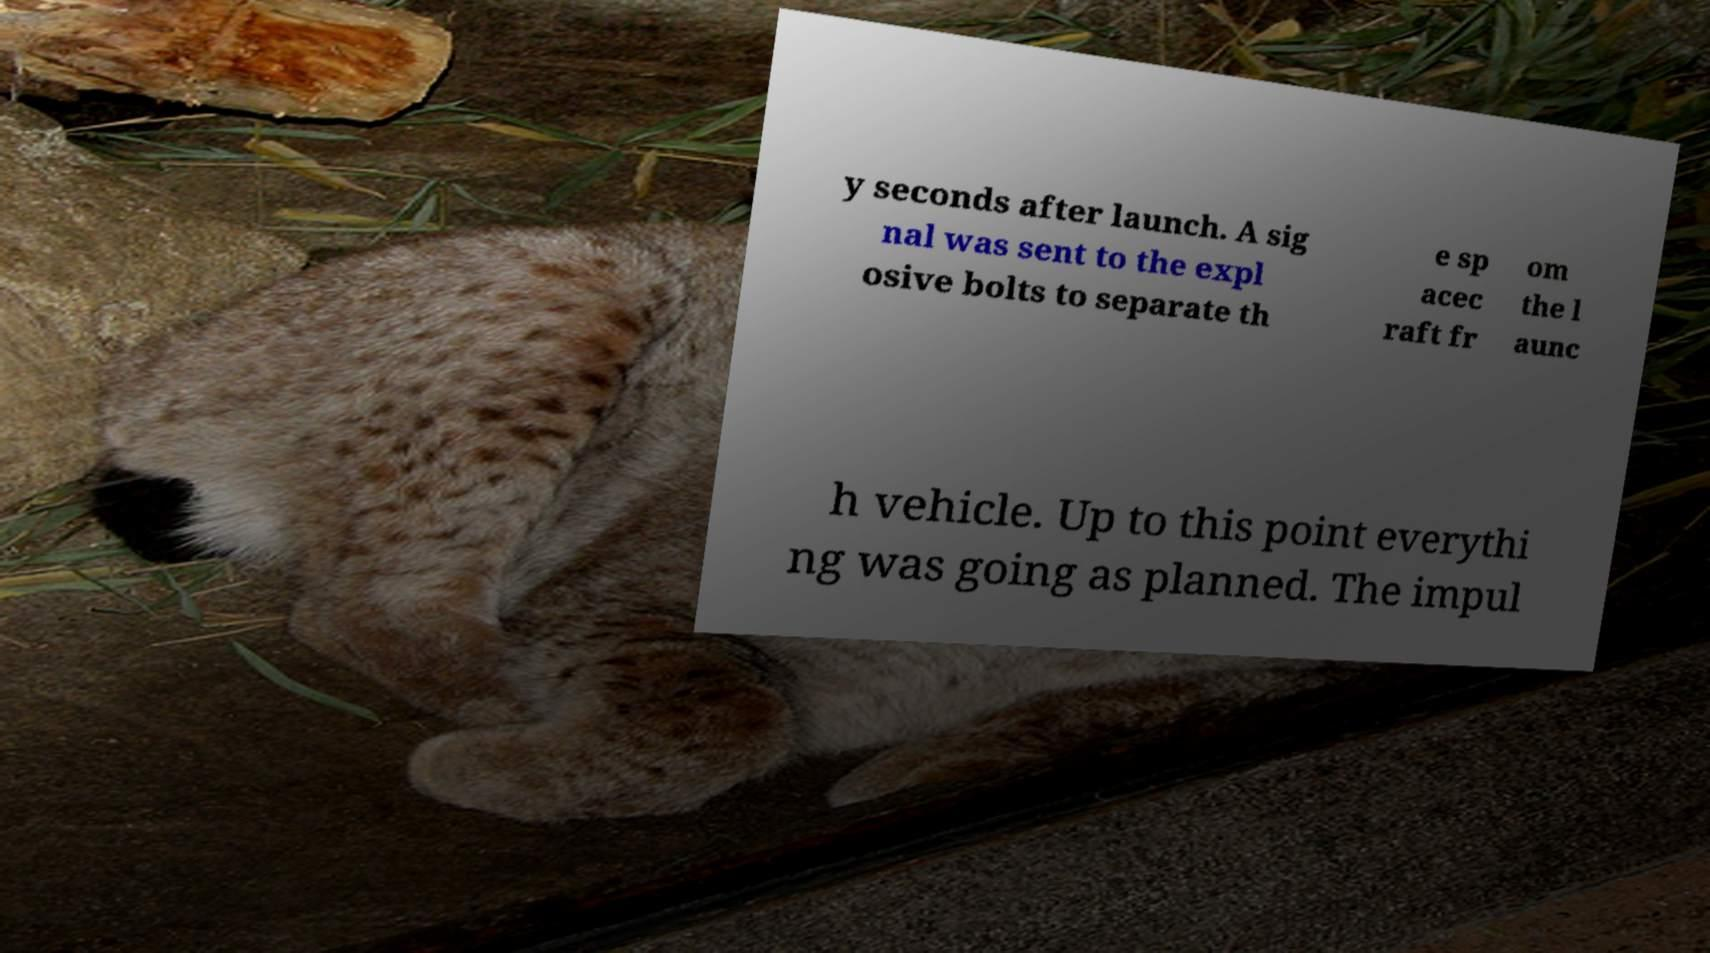Please read and relay the text visible in this image. What does it say? y seconds after launch. A sig nal was sent to the expl osive bolts to separate th e sp acec raft fr om the l aunc h vehicle. Up to this point everythi ng was going as planned. The impul 